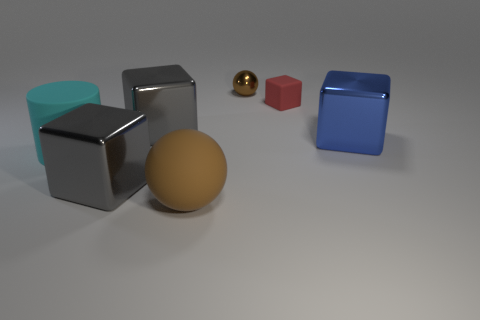Subtract all yellow blocks. Subtract all blue balls. How many blocks are left? 4 Add 1 large cylinders. How many objects exist? 8 Subtract all cubes. How many objects are left? 3 Add 3 large gray metallic cubes. How many large gray metallic cubes exist? 5 Subtract 0 blue balls. How many objects are left? 7 Subtract all brown objects. Subtract all red rubber objects. How many objects are left? 4 Add 6 metallic things. How many metallic things are left? 10 